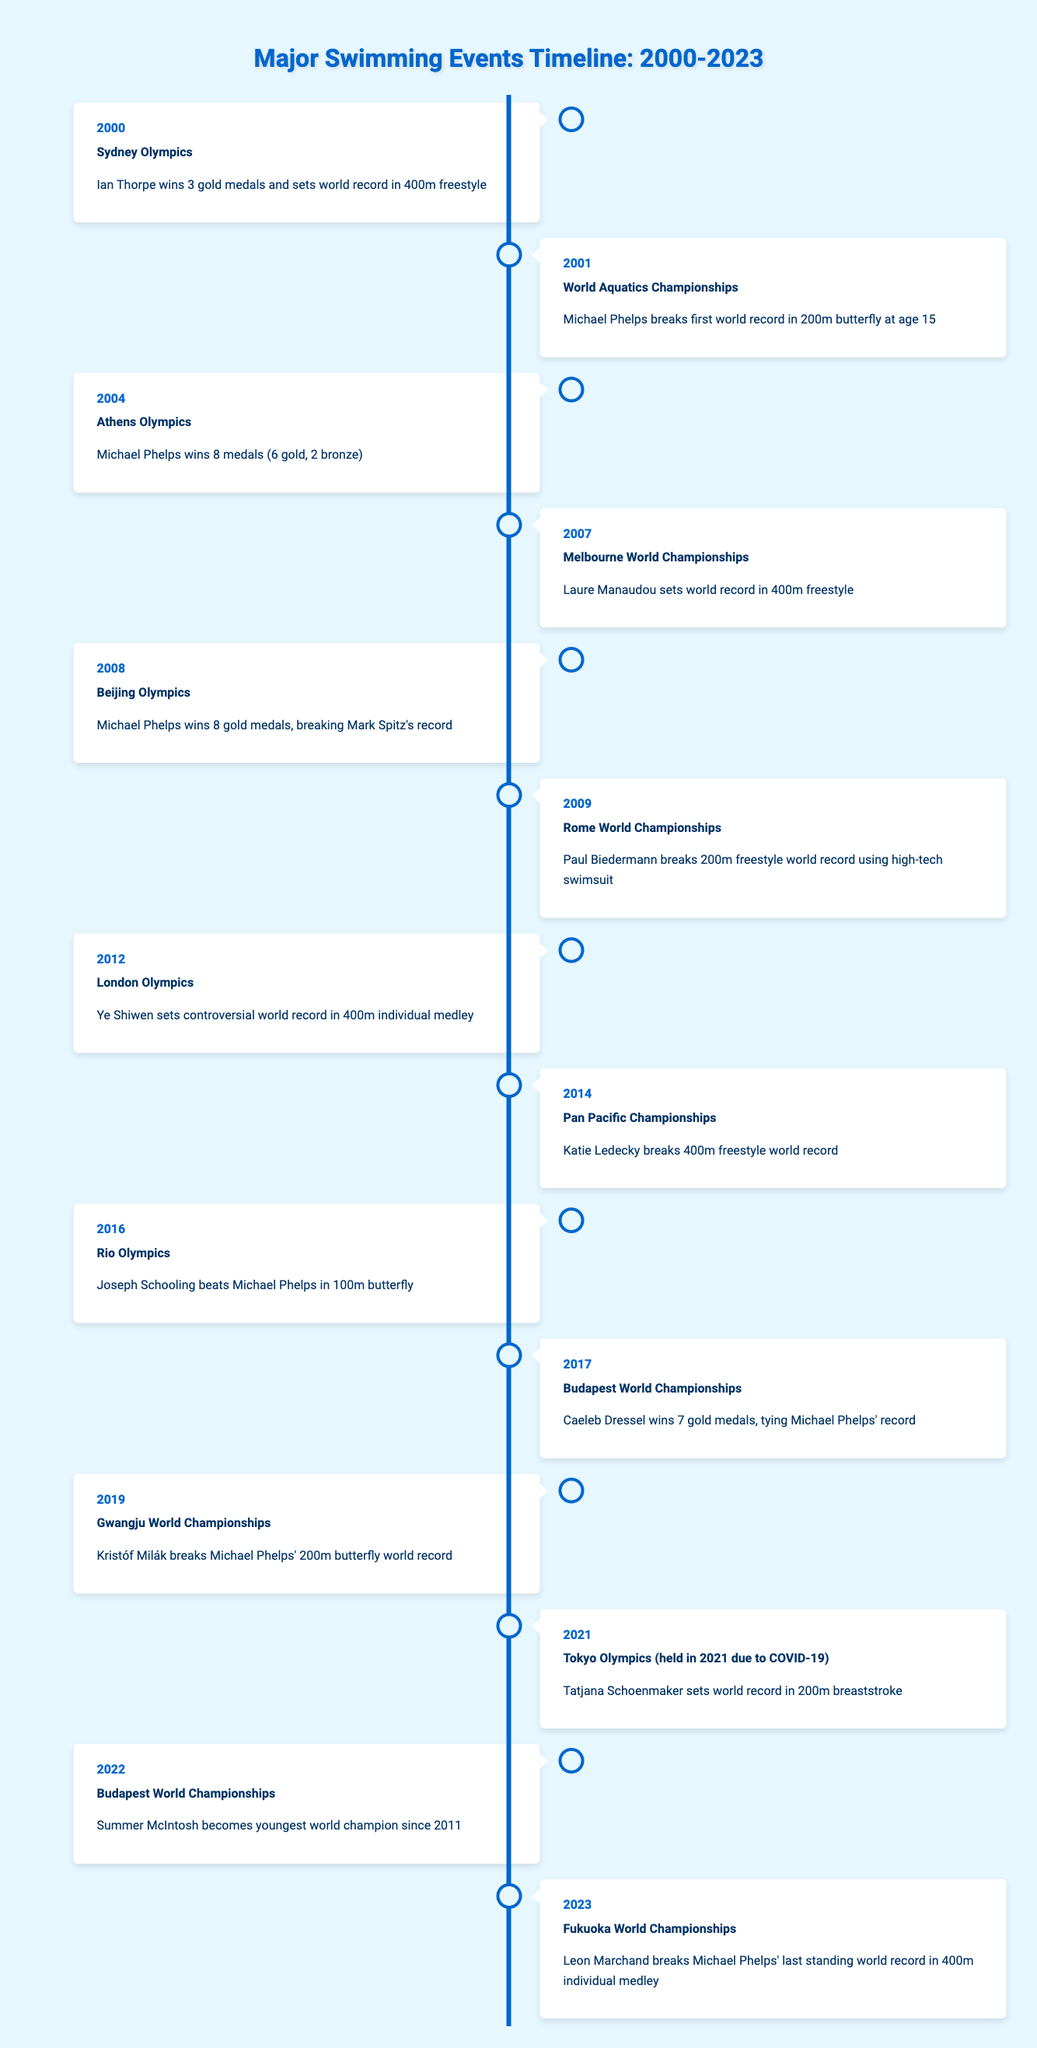What year did Michael Phelps win 8 medals at the Olympics? According to the table, Michael Phelps won 8 medals during the Athens Olympics in the year 2004.
Answer: 2004 Which swimmer set a world record in the 400m individual medley in 2012? The table shows that Ye Shiwen set a controversial world record in the 400m individual medley during the London Olympics in 2012.
Answer: Ye Shiwen How many years passed between Katie Ledecky's world record in 400m freestyle and Tatjana Schoenmaker's world record in 200m breaststroke? Katie Ledecky broke the 400m freestyle world record in 2014, and Tatjana Schoenmaker set the 200m breaststroke world record in 2021. The difference is 2021 - 2014 = 7 years.
Answer: 7 years Did Paul Biedermann break a world record at the Rome World Championships? Yes, the table states that Paul Biedermann broke the 200m freestyle world record at the Rome World Championships in 2009.
Answer: Yes Which swimmer broke Michael Phelps' last standing world record and in what year? The table indicates that Leon Marchand broke Michael Phelps' last standing world record in the 400m individual medley during the Fukuoka World Championships in 2023.
Answer: Leon Marchand in 2023 What is the total number of Olympic events listed in the timeline? The timeline includes events from the Olympics in 2000, 2004, 2008, 2012, 2016, and 2021. This totals to 6 Olympic events.
Answer: 6 Which swimmer won the most gold medals at a World Championships event according to the table? The table indicates that Caeleb Dressel won 7 gold medals at the Budapest World Championships in 2017, which is the highest number listed.
Answer: Caeleb Dressel Was Michael Phelps the only swimmer to achieve 8 medals in a single Olympics? Yes, the table only mentions Michael Phelps achieving 8 medals during the Athens Olympics in 2004, with no other swimmers noted to have reached that number.
Answer: Yes 